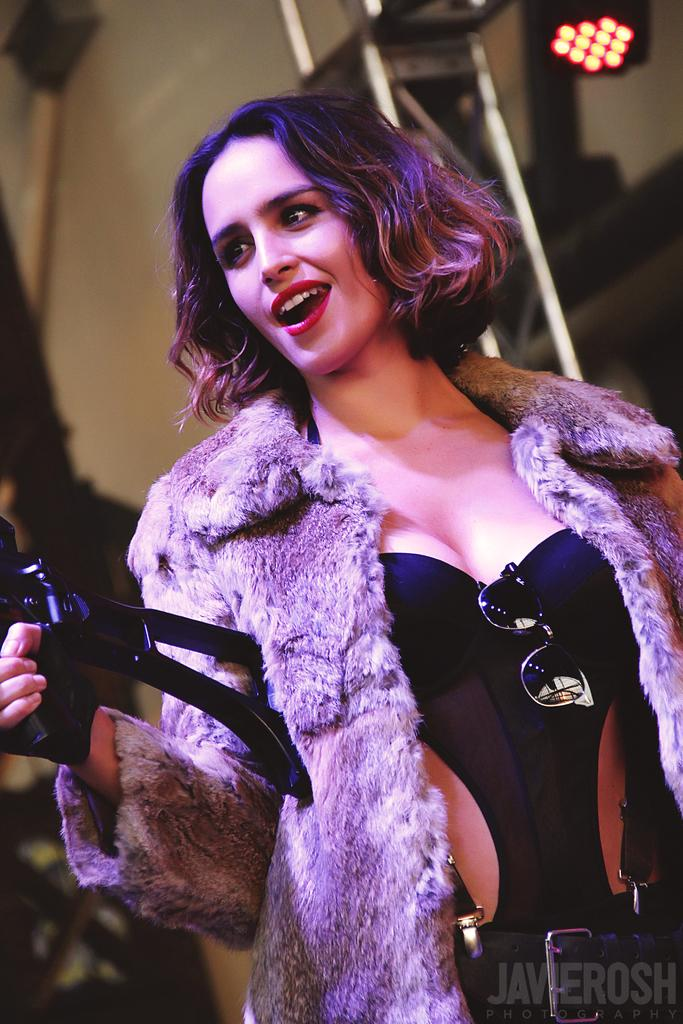Who is the main subject in the image? There is a girl in the image. What is the girl doing in the image? The girl is standing in the image. What is the girl holding in the image? The girl is holding an object in the image. What can be seen in the background of the image? There is a building in the background of the image. What type of clam is the girl holding in the image? There is no clam present in the image; the girl is holding an object, but it is not specified as a clam. 